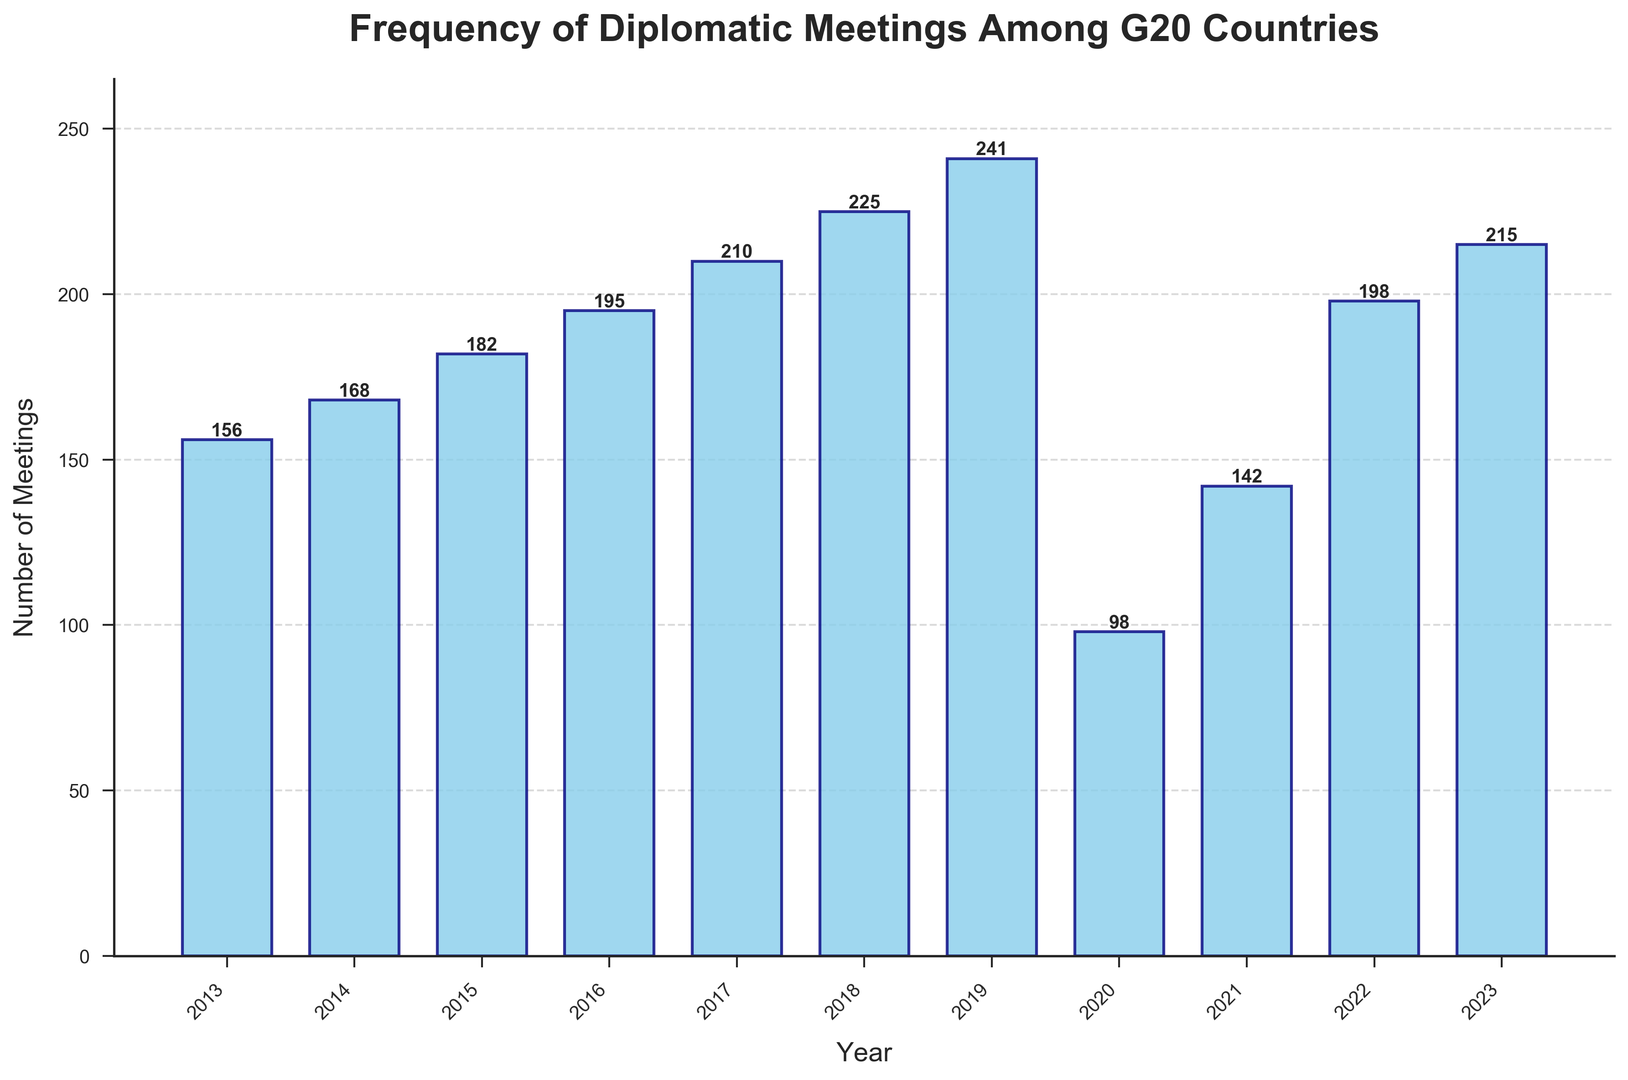What is the highest number of diplomatic meetings recorded in a single year? The highest bar corresponds to the year 2019 with a height of 241 meetings, which is the tallest among all years.
Answer: 241 How many more meetings were held in 2023 compared to 2020? The figure shows 215 meetings in 2023 and 98 in 2020. The difference is 215 - 98.
Answer: 117 What is the average number of meetings per year over the past decade? Sum all the meetings from 2013 to 2023 (156+168+182+195+210+225+241+98+142+198+215) to get 2030, then divide by the number of years, which is 11. So, 2030 / 11.
Answer: 184.55 In which year did the number of meetings decrease the most compared to the previous year? The number of meetings decreased the most between 2019 and 2020, dropping from 241 to 98.
Answer: 2020 Which year shows the highest increase in the number of meetings compared to the previous year? The largest increase happened between 2020 (98 meetings) and 2021 (142 meetings). The increase is 142 - 98.
Answer: 2021 How many years had more than 200 meetings? The bars exceeding the 200 mark are for the years 2017, 2018, 2019, 2022, and 2023, totaling 5 years.
Answer: 5 Which year had the lowest number of meetings, and what was that number? The year with the shortest bar is 2020, with 98 meetings.
Answer: 2020, 98 What is the median number of meetings from 2013 to 2023? Listing the number of meetings in ascending order: 98, 142, 156, 168, 182, 195, 198, 210, 215, 225, 241. The median is the middle value in this list, which is 195.
Answer: 195 How many more meetings were held in 2019 compared to 2013? The figure shows 241 meetings in 2019 and 156 in 2013. The difference is 241 - 156.
Answer: 85 In which years were the number of meetings between 150 and 200 (inclusive)? The bars corresponding to the number of meetings between 150 and 200 are for the years 2013, 2014, 2015, 2016, 2020, and 2021.
Answer: 2013, 2014, 2015, 2016, 2020, 2021 